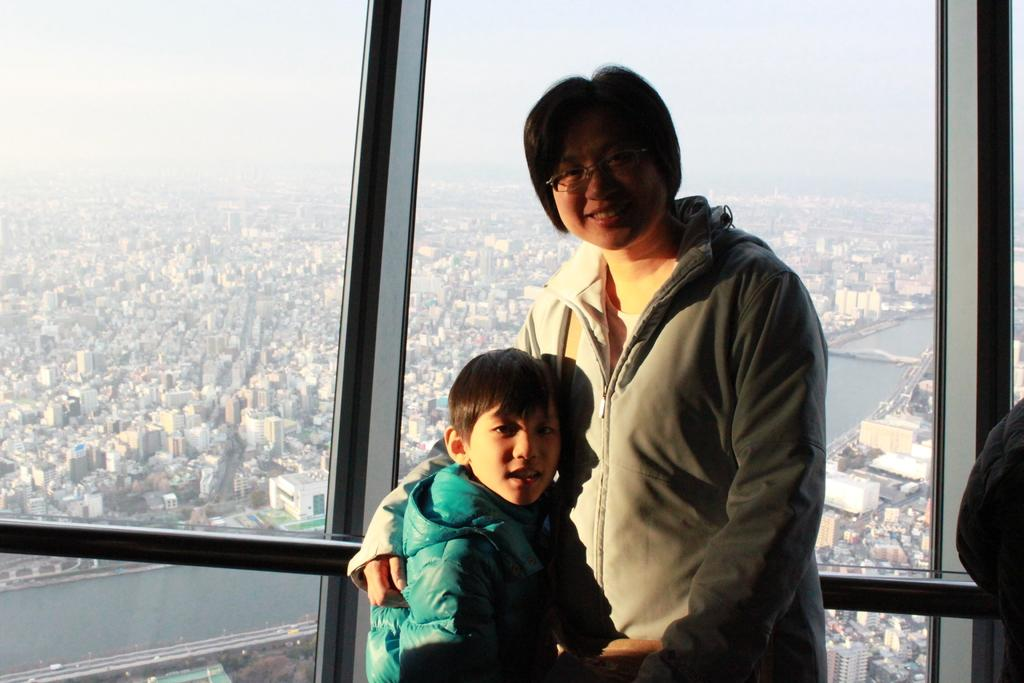Who is present in the image? There is a boy and a person in the image. What are they wearing? Both the boy and the person are wearing jackets. What can be seen in the background of the image? There are buildings in the background of the image. What is in the center of the image? There is a river in the center of the image. What type of yam is being stored in the cellar in the image? There is no cellar or yam present in the image. Is the parent of the boy visible in the image? The provided facts do not mention the relationship between the boy and the person, so we cannot determine if the person is the boy's parent. 